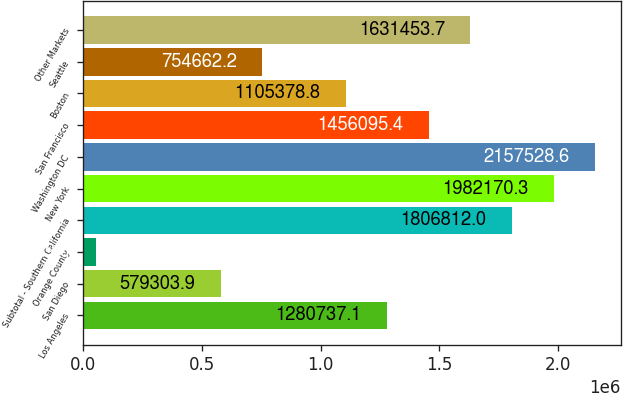Convert chart. <chart><loc_0><loc_0><loc_500><loc_500><bar_chart><fcel>Los Angeles<fcel>San Diego<fcel>Orange County<fcel>Subtotal - Southern California<fcel>New York<fcel>Washington DC<fcel>San Francisco<fcel>Boston<fcel>Seattle<fcel>Other Markets<nl><fcel>1.28074e+06<fcel>579304<fcel>53229<fcel>1.80681e+06<fcel>1.98217e+06<fcel>2.15753e+06<fcel>1.4561e+06<fcel>1.10538e+06<fcel>754662<fcel>1.63145e+06<nl></chart> 